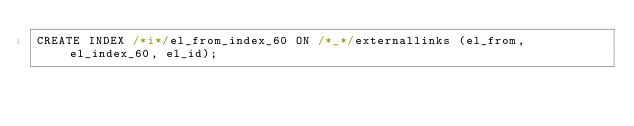<code> <loc_0><loc_0><loc_500><loc_500><_SQL_>CREATE INDEX /*i*/el_from_index_60 ON /*_*/externallinks (el_from, el_index_60, el_id);
</code> 